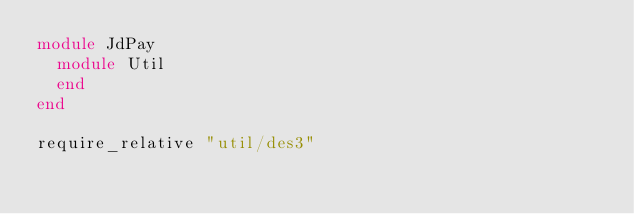<code> <loc_0><loc_0><loc_500><loc_500><_Ruby_>module JdPay
  module Util
  end
end

require_relative "util/des3"
</code> 